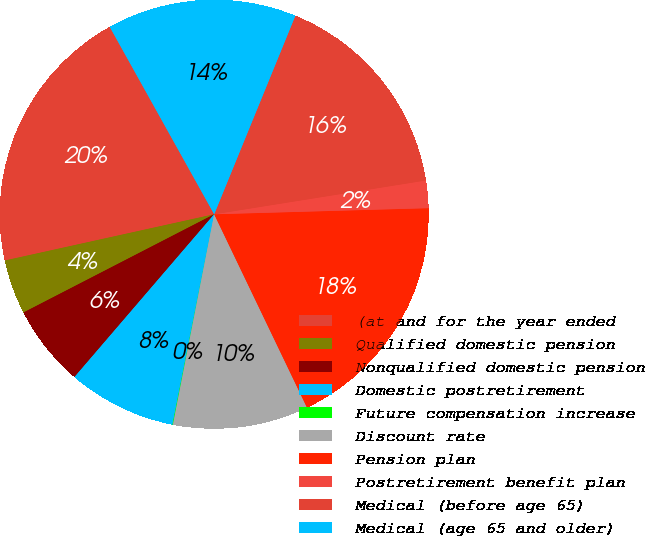Convert chart to OTSL. <chart><loc_0><loc_0><loc_500><loc_500><pie_chart><fcel>(at and for the year ended<fcel>Qualified domestic pension<fcel>Nonqualified domestic pension<fcel>Domestic postretirement<fcel>Future compensation increase<fcel>Discount rate<fcel>Pension plan<fcel>Postretirement benefit plan<fcel>Medical (before age 65)<fcel>Medical (age 65 and older)<nl><fcel>20.37%<fcel>4.11%<fcel>6.14%<fcel>8.17%<fcel>0.04%<fcel>10.2%<fcel>18.33%<fcel>2.07%<fcel>16.3%<fcel>14.27%<nl></chart> 